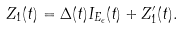<formula> <loc_0><loc_0><loc_500><loc_500>Z _ { 1 } ( t ) = \Delta ( t ) I _ { E _ { \epsilon } } ( t ) + Z _ { 1 } ^ { \prime } ( t ) .</formula> 